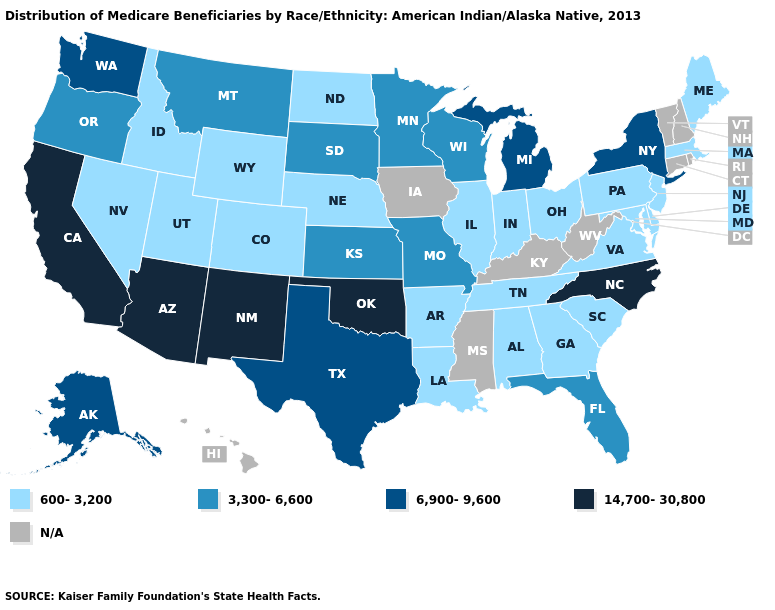Which states hav the highest value in the Northeast?
Give a very brief answer. New York. What is the highest value in the Northeast ?
Short answer required. 6,900-9,600. What is the value of Florida?
Concise answer only. 3,300-6,600. What is the value of Wisconsin?
Concise answer only. 3,300-6,600. Does the first symbol in the legend represent the smallest category?
Quick response, please. Yes. What is the lowest value in the South?
Concise answer only. 600-3,200. What is the value of Virginia?
Be succinct. 600-3,200. Does the map have missing data?
Be succinct. Yes. Name the states that have a value in the range 14,700-30,800?
Quick response, please. Arizona, California, New Mexico, North Carolina, Oklahoma. Name the states that have a value in the range 14,700-30,800?
Give a very brief answer. Arizona, California, New Mexico, North Carolina, Oklahoma. What is the lowest value in states that border Wisconsin?
Concise answer only. 600-3,200. Which states have the lowest value in the USA?
Be succinct. Alabama, Arkansas, Colorado, Delaware, Georgia, Idaho, Illinois, Indiana, Louisiana, Maine, Maryland, Massachusetts, Nebraska, Nevada, New Jersey, North Dakota, Ohio, Pennsylvania, South Carolina, Tennessee, Utah, Virginia, Wyoming. Does the first symbol in the legend represent the smallest category?
Give a very brief answer. Yes. 